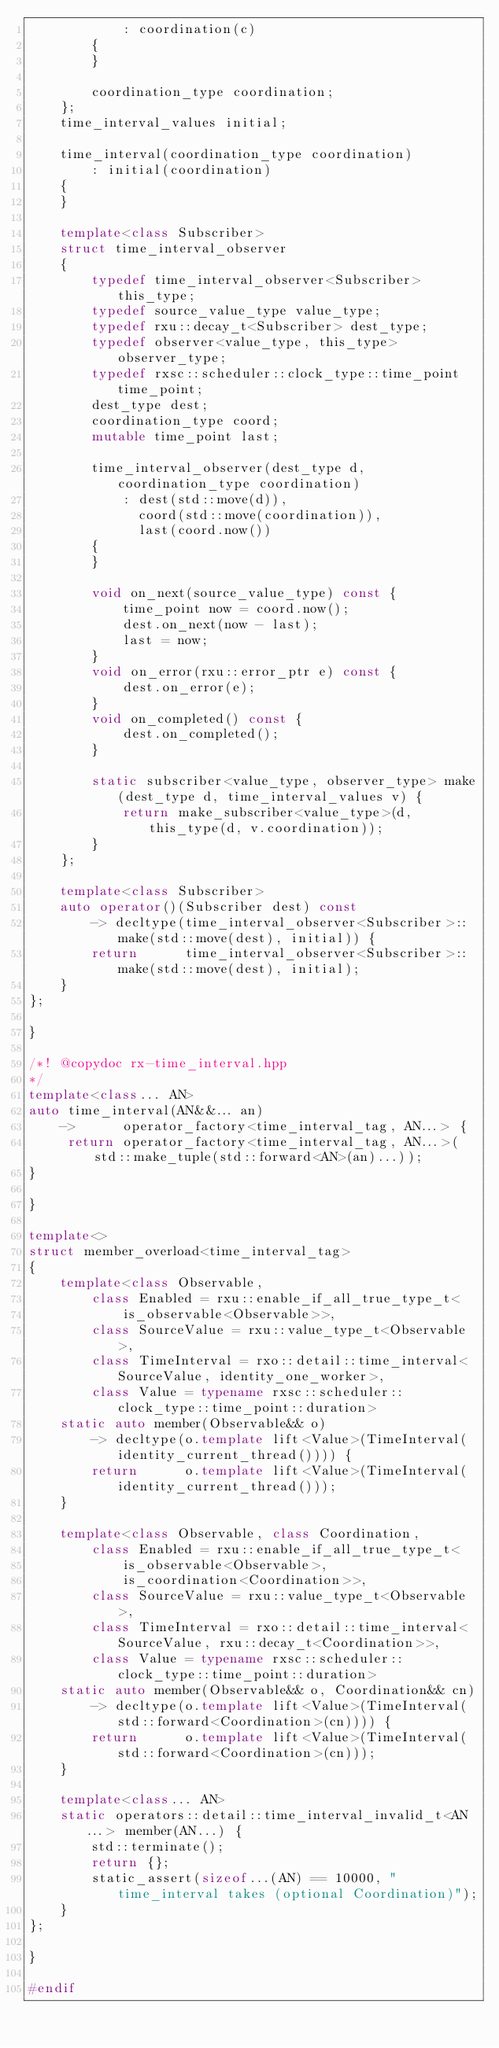Convert code to text. <code><loc_0><loc_0><loc_500><loc_500><_C++_>            : coordination(c)
        {
        }

        coordination_type coordination;
    };
    time_interval_values initial;

    time_interval(coordination_type coordination)
        : initial(coordination)
    {
    }

    template<class Subscriber>
    struct time_interval_observer
    {
        typedef time_interval_observer<Subscriber> this_type;
        typedef source_value_type value_type;
        typedef rxu::decay_t<Subscriber> dest_type;
        typedef observer<value_type, this_type> observer_type;
        typedef rxsc::scheduler::clock_type::time_point time_point;
        dest_type dest;
        coordination_type coord;
        mutable time_point last;

        time_interval_observer(dest_type d, coordination_type coordination)
            : dest(std::move(d)),
              coord(std::move(coordination)),
              last(coord.now())
        {
        }

        void on_next(source_value_type) const {
            time_point now = coord.now();
            dest.on_next(now - last);
            last = now;
        }
        void on_error(rxu::error_ptr e) const {
            dest.on_error(e);
        }
        void on_completed() const {
            dest.on_completed();
        }

        static subscriber<value_type, observer_type> make(dest_type d, time_interval_values v) {
            return make_subscriber<value_type>(d, this_type(d, v.coordination));
        }
    };

    template<class Subscriber>
    auto operator()(Subscriber dest) const
        -> decltype(time_interval_observer<Subscriber>::make(std::move(dest), initial)) {
        return      time_interval_observer<Subscriber>::make(std::move(dest), initial);
    }
};

}

/*! @copydoc rx-time_interval.hpp
*/
template<class... AN>
auto time_interval(AN&&... an)
    ->      operator_factory<time_interval_tag, AN...> {
     return operator_factory<time_interval_tag, AN...>(std::make_tuple(std::forward<AN>(an)...));
}

}

template<>
struct member_overload<time_interval_tag>
{
    template<class Observable,
        class Enabled = rxu::enable_if_all_true_type_t<
            is_observable<Observable>>,
        class SourceValue = rxu::value_type_t<Observable>,
        class TimeInterval = rxo::detail::time_interval<SourceValue, identity_one_worker>,
        class Value = typename rxsc::scheduler::clock_type::time_point::duration>
    static auto member(Observable&& o)
        -> decltype(o.template lift<Value>(TimeInterval(identity_current_thread()))) {
        return      o.template lift<Value>(TimeInterval(identity_current_thread()));
    }

    template<class Observable, class Coordination,
        class Enabled = rxu::enable_if_all_true_type_t<
            is_observable<Observable>,
            is_coordination<Coordination>>,
        class SourceValue = rxu::value_type_t<Observable>,
        class TimeInterval = rxo::detail::time_interval<SourceValue, rxu::decay_t<Coordination>>,
        class Value = typename rxsc::scheduler::clock_type::time_point::duration>
    static auto member(Observable&& o, Coordination&& cn)
        -> decltype(o.template lift<Value>(TimeInterval(std::forward<Coordination>(cn)))) {
        return      o.template lift<Value>(TimeInterval(std::forward<Coordination>(cn)));
    }

    template<class... AN>
    static operators::detail::time_interval_invalid_t<AN...> member(AN...) {
        std::terminate();
        return {};
        static_assert(sizeof...(AN) == 10000, "time_interval takes (optional Coordination)");
    }
};

}

#endif
</code> 